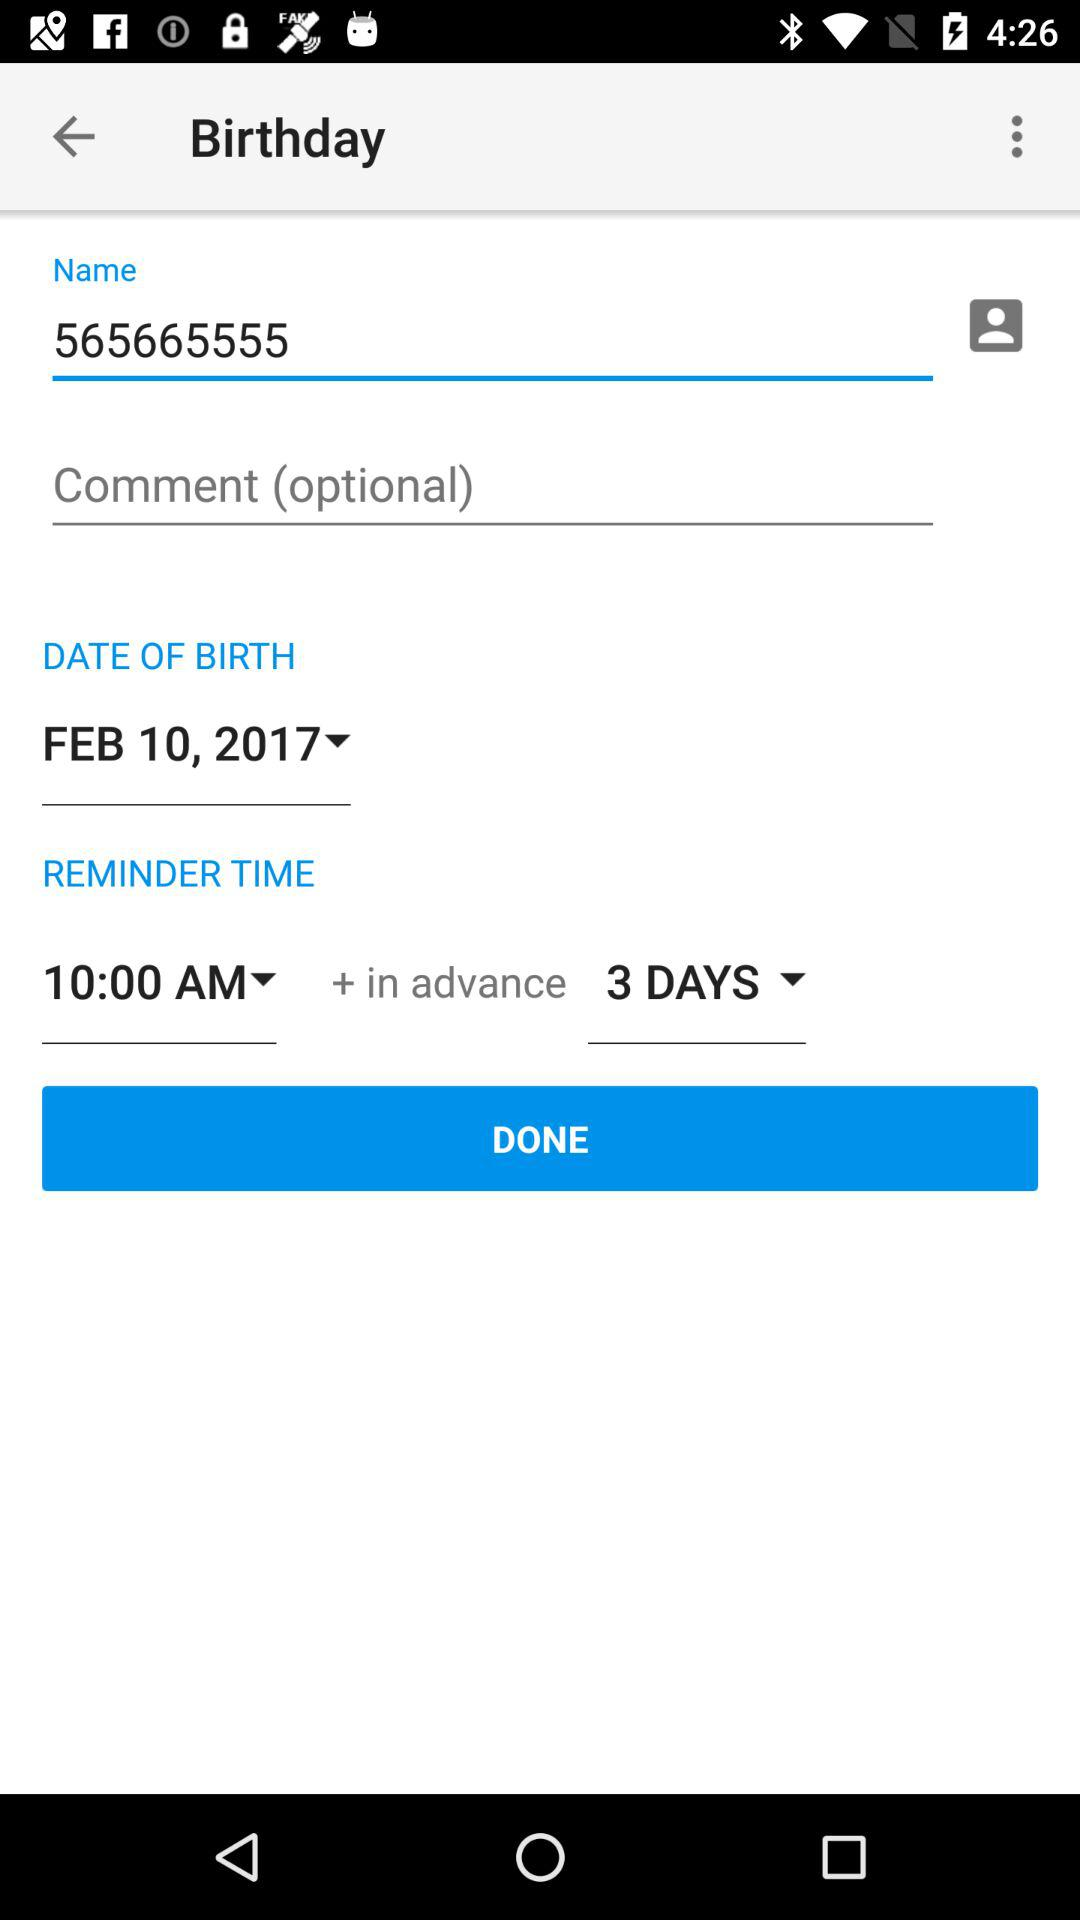What is written in the name field? In the name field, "565665555" is written. 